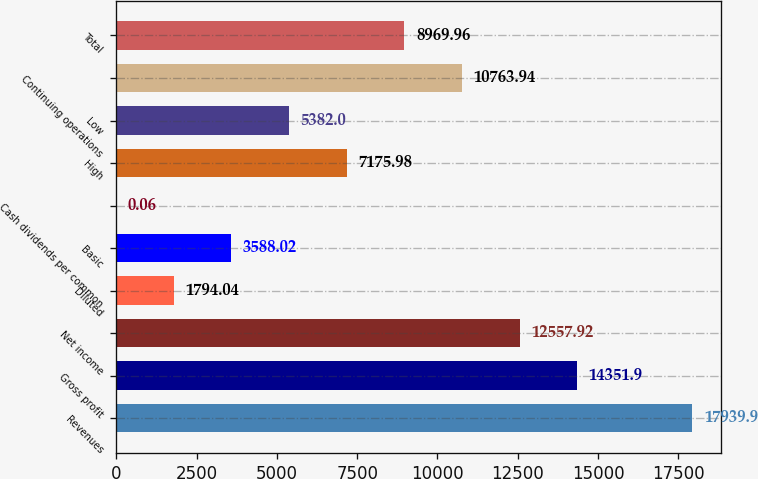<chart> <loc_0><loc_0><loc_500><loc_500><bar_chart><fcel>Revenues<fcel>Gross profit<fcel>Net income<fcel>Diluted<fcel>Basic<fcel>Cash dividends per common<fcel>High<fcel>Low<fcel>Continuing operations<fcel>Total<nl><fcel>17939.9<fcel>14351.9<fcel>12557.9<fcel>1794.04<fcel>3588.02<fcel>0.06<fcel>7175.98<fcel>5382<fcel>10763.9<fcel>8969.96<nl></chart> 